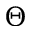<formula> <loc_0><loc_0><loc_500><loc_500>\Theta</formula> 